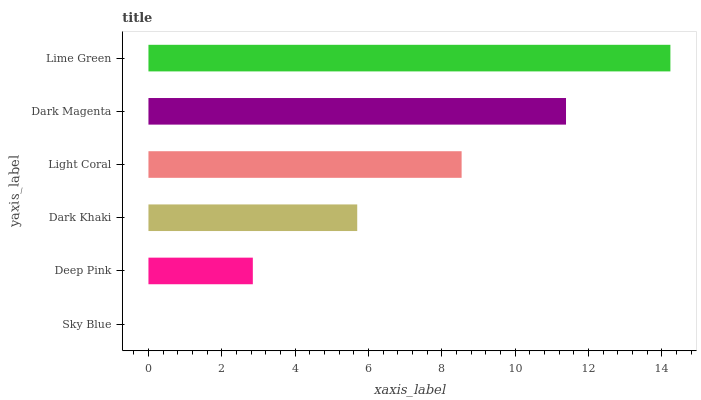Is Sky Blue the minimum?
Answer yes or no. Yes. Is Lime Green the maximum?
Answer yes or no. Yes. Is Deep Pink the minimum?
Answer yes or no. No. Is Deep Pink the maximum?
Answer yes or no. No. Is Deep Pink greater than Sky Blue?
Answer yes or no. Yes. Is Sky Blue less than Deep Pink?
Answer yes or no. Yes. Is Sky Blue greater than Deep Pink?
Answer yes or no. No. Is Deep Pink less than Sky Blue?
Answer yes or no. No. Is Light Coral the high median?
Answer yes or no. Yes. Is Dark Khaki the low median?
Answer yes or no. Yes. Is Dark Khaki the high median?
Answer yes or no. No. Is Dark Magenta the low median?
Answer yes or no. No. 